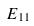<formula> <loc_0><loc_0><loc_500><loc_500>E _ { 1 1 }</formula> 